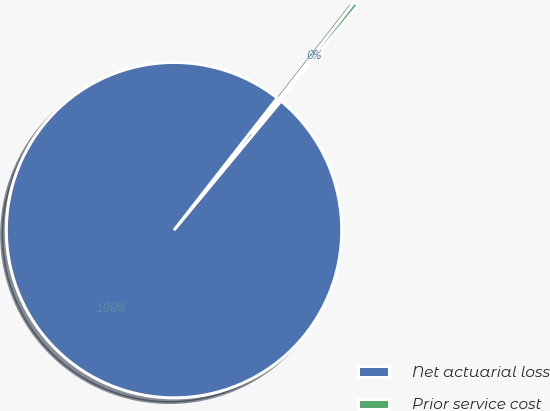<chart> <loc_0><loc_0><loc_500><loc_500><pie_chart><fcel>Net actuarial loss<fcel>Prior service cost<nl><fcel>99.54%<fcel>0.46%<nl></chart> 